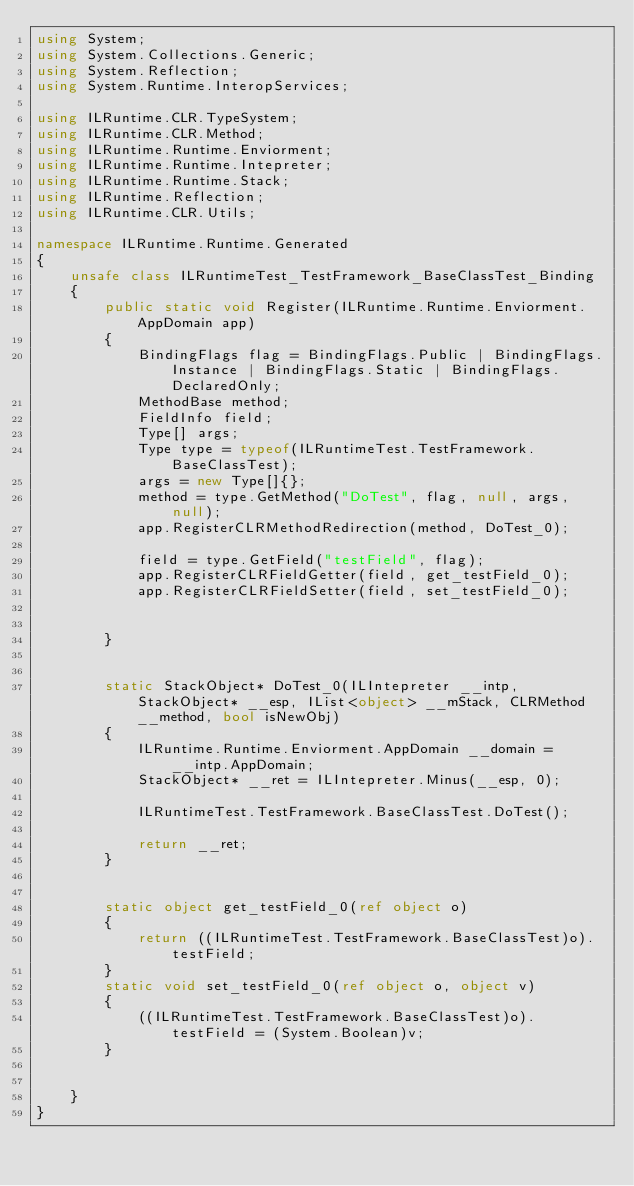Convert code to text. <code><loc_0><loc_0><loc_500><loc_500><_C#_>using System;
using System.Collections.Generic;
using System.Reflection;
using System.Runtime.InteropServices;

using ILRuntime.CLR.TypeSystem;
using ILRuntime.CLR.Method;
using ILRuntime.Runtime.Enviorment;
using ILRuntime.Runtime.Intepreter;
using ILRuntime.Runtime.Stack;
using ILRuntime.Reflection;
using ILRuntime.CLR.Utils;

namespace ILRuntime.Runtime.Generated
{
    unsafe class ILRuntimeTest_TestFramework_BaseClassTest_Binding
    {
        public static void Register(ILRuntime.Runtime.Enviorment.AppDomain app)
        {
            BindingFlags flag = BindingFlags.Public | BindingFlags.Instance | BindingFlags.Static | BindingFlags.DeclaredOnly;
            MethodBase method;
            FieldInfo field;
            Type[] args;
            Type type = typeof(ILRuntimeTest.TestFramework.BaseClassTest);
            args = new Type[]{};
            method = type.GetMethod("DoTest", flag, null, args, null);
            app.RegisterCLRMethodRedirection(method, DoTest_0);

            field = type.GetField("testField", flag);
            app.RegisterCLRFieldGetter(field, get_testField_0);
            app.RegisterCLRFieldSetter(field, set_testField_0);


        }


        static StackObject* DoTest_0(ILIntepreter __intp, StackObject* __esp, IList<object> __mStack, CLRMethod __method, bool isNewObj)
        {
            ILRuntime.Runtime.Enviorment.AppDomain __domain = __intp.AppDomain;
            StackObject* __ret = ILIntepreter.Minus(__esp, 0);

            ILRuntimeTest.TestFramework.BaseClassTest.DoTest();

            return __ret;
        }


        static object get_testField_0(ref object o)
        {
            return ((ILRuntimeTest.TestFramework.BaseClassTest)o).testField;
        }
        static void set_testField_0(ref object o, object v)
        {
            ((ILRuntimeTest.TestFramework.BaseClassTest)o).testField = (System.Boolean)v;
        }


    }
}
</code> 